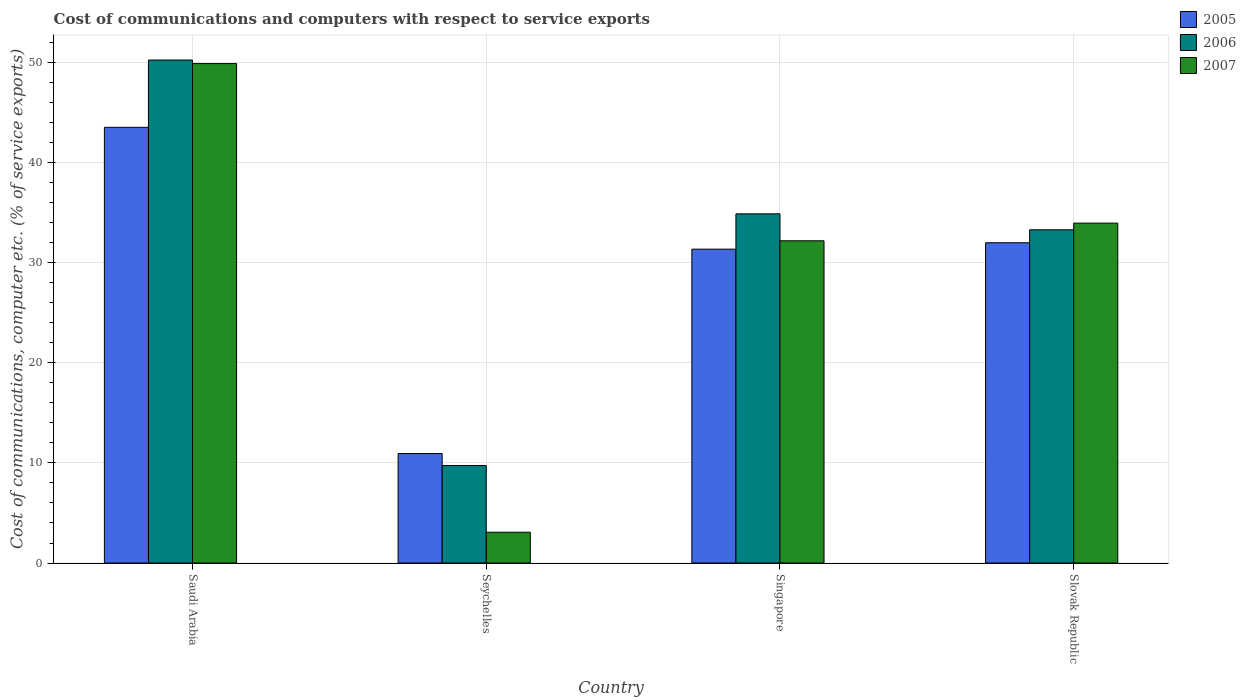How many different coloured bars are there?
Make the answer very short. 3. What is the label of the 1st group of bars from the left?
Provide a succinct answer. Saudi Arabia. What is the cost of communications and computers in 2007 in Seychelles?
Make the answer very short. 3.08. Across all countries, what is the maximum cost of communications and computers in 2006?
Offer a very short reply. 50.22. Across all countries, what is the minimum cost of communications and computers in 2006?
Your response must be concise. 9.74. In which country was the cost of communications and computers in 2007 maximum?
Your answer should be very brief. Saudi Arabia. In which country was the cost of communications and computers in 2006 minimum?
Offer a very short reply. Seychelles. What is the total cost of communications and computers in 2005 in the graph?
Your answer should be very brief. 117.76. What is the difference between the cost of communications and computers in 2007 in Seychelles and that in Slovak Republic?
Keep it short and to the point. -30.86. What is the difference between the cost of communications and computers in 2007 in Saudi Arabia and the cost of communications and computers in 2006 in Seychelles?
Your answer should be very brief. 40.13. What is the average cost of communications and computers in 2007 per country?
Your answer should be compact. 29.77. What is the difference between the cost of communications and computers of/in 2006 and cost of communications and computers of/in 2007 in Slovak Republic?
Provide a succinct answer. -0.67. In how many countries, is the cost of communications and computers in 2007 greater than 8 %?
Your answer should be compact. 3. What is the ratio of the cost of communications and computers in 2007 in Singapore to that in Slovak Republic?
Ensure brevity in your answer.  0.95. Is the cost of communications and computers in 2005 in Saudi Arabia less than that in Slovak Republic?
Make the answer very short. No. What is the difference between the highest and the second highest cost of communications and computers in 2005?
Your answer should be very brief. 12.17. What is the difference between the highest and the lowest cost of communications and computers in 2007?
Make the answer very short. 46.79. In how many countries, is the cost of communications and computers in 2005 greater than the average cost of communications and computers in 2005 taken over all countries?
Offer a very short reply. 3. What does the 1st bar from the left in Slovak Republic represents?
Offer a very short reply. 2005. Is it the case that in every country, the sum of the cost of communications and computers in 2007 and cost of communications and computers in 2005 is greater than the cost of communications and computers in 2006?
Keep it short and to the point. Yes. Are all the bars in the graph horizontal?
Offer a very short reply. No. How many legend labels are there?
Give a very brief answer. 3. What is the title of the graph?
Ensure brevity in your answer.  Cost of communications and computers with respect to service exports. Does "1985" appear as one of the legend labels in the graph?
Give a very brief answer. No. What is the label or title of the X-axis?
Offer a very short reply. Country. What is the label or title of the Y-axis?
Offer a terse response. Cost of communications, computer etc. (% of service exports). What is the Cost of communications, computer etc. (% of service exports) in 2005 in Saudi Arabia?
Your answer should be compact. 43.5. What is the Cost of communications, computer etc. (% of service exports) in 2006 in Saudi Arabia?
Your response must be concise. 50.22. What is the Cost of communications, computer etc. (% of service exports) of 2007 in Saudi Arabia?
Provide a short and direct response. 49.87. What is the Cost of communications, computer etc. (% of service exports) of 2005 in Seychelles?
Provide a succinct answer. 10.93. What is the Cost of communications, computer etc. (% of service exports) of 2006 in Seychelles?
Offer a terse response. 9.74. What is the Cost of communications, computer etc. (% of service exports) of 2007 in Seychelles?
Your response must be concise. 3.08. What is the Cost of communications, computer etc. (% of service exports) of 2005 in Singapore?
Give a very brief answer. 31.34. What is the Cost of communications, computer etc. (% of service exports) in 2006 in Singapore?
Your answer should be very brief. 34.87. What is the Cost of communications, computer etc. (% of service exports) in 2007 in Singapore?
Make the answer very short. 32.18. What is the Cost of communications, computer etc. (% of service exports) in 2005 in Slovak Republic?
Give a very brief answer. 31.98. What is the Cost of communications, computer etc. (% of service exports) of 2006 in Slovak Republic?
Your response must be concise. 33.27. What is the Cost of communications, computer etc. (% of service exports) in 2007 in Slovak Republic?
Ensure brevity in your answer.  33.94. Across all countries, what is the maximum Cost of communications, computer etc. (% of service exports) of 2005?
Keep it short and to the point. 43.5. Across all countries, what is the maximum Cost of communications, computer etc. (% of service exports) in 2006?
Your answer should be compact. 50.22. Across all countries, what is the maximum Cost of communications, computer etc. (% of service exports) in 2007?
Your response must be concise. 49.87. Across all countries, what is the minimum Cost of communications, computer etc. (% of service exports) of 2005?
Offer a very short reply. 10.93. Across all countries, what is the minimum Cost of communications, computer etc. (% of service exports) of 2006?
Give a very brief answer. 9.74. Across all countries, what is the minimum Cost of communications, computer etc. (% of service exports) of 2007?
Provide a succinct answer. 3.08. What is the total Cost of communications, computer etc. (% of service exports) in 2005 in the graph?
Your response must be concise. 117.76. What is the total Cost of communications, computer etc. (% of service exports) of 2006 in the graph?
Your response must be concise. 128.1. What is the total Cost of communications, computer etc. (% of service exports) in 2007 in the graph?
Make the answer very short. 119.06. What is the difference between the Cost of communications, computer etc. (% of service exports) in 2005 in Saudi Arabia and that in Seychelles?
Your answer should be very brief. 32.57. What is the difference between the Cost of communications, computer etc. (% of service exports) of 2006 in Saudi Arabia and that in Seychelles?
Provide a succinct answer. 40.49. What is the difference between the Cost of communications, computer etc. (% of service exports) of 2007 in Saudi Arabia and that in Seychelles?
Your answer should be compact. 46.79. What is the difference between the Cost of communications, computer etc. (% of service exports) in 2005 in Saudi Arabia and that in Singapore?
Give a very brief answer. 12.17. What is the difference between the Cost of communications, computer etc. (% of service exports) in 2006 in Saudi Arabia and that in Singapore?
Offer a terse response. 15.36. What is the difference between the Cost of communications, computer etc. (% of service exports) in 2007 in Saudi Arabia and that in Singapore?
Offer a terse response. 17.69. What is the difference between the Cost of communications, computer etc. (% of service exports) in 2005 in Saudi Arabia and that in Slovak Republic?
Ensure brevity in your answer.  11.52. What is the difference between the Cost of communications, computer etc. (% of service exports) of 2006 in Saudi Arabia and that in Slovak Republic?
Give a very brief answer. 16.95. What is the difference between the Cost of communications, computer etc. (% of service exports) in 2007 in Saudi Arabia and that in Slovak Republic?
Provide a short and direct response. 15.93. What is the difference between the Cost of communications, computer etc. (% of service exports) in 2005 in Seychelles and that in Singapore?
Your response must be concise. -20.41. What is the difference between the Cost of communications, computer etc. (% of service exports) of 2006 in Seychelles and that in Singapore?
Ensure brevity in your answer.  -25.13. What is the difference between the Cost of communications, computer etc. (% of service exports) of 2007 in Seychelles and that in Singapore?
Give a very brief answer. -29.1. What is the difference between the Cost of communications, computer etc. (% of service exports) of 2005 in Seychelles and that in Slovak Republic?
Give a very brief answer. -21.05. What is the difference between the Cost of communications, computer etc. (% of service exports) in 2006 in Seychelles and that in Slovak Republic?
Ensure brevity in your answer.  -23.54. What is the difference between the Cost of communications, computer etc. (% of service exports) in 2007 in Seychelles and that in Slovak Republic?
Your answer should be very brief. -30.86. What is the difference between the Cost of communications, computer etc. (% of service exports) in 2005 in Singapore and that in Slovak Republic?
Your answer should be compact. -0.64. What is the difference between the Cost of communications, computer etc. (% of service exports) of 2006 in Singapore and that in Slovak Republic?
Keep it short and to the point. 1.6. What is the difference between the Cost of communications, computer etc. (% of service exports) in 2007 in Singapore and that in Slovak Republic?
Provide a short and direct response. -1.76. What is the difference between the Cost of communications, computer etc. (% of service exports) of 2005 in Saudi Arabia and the Cost of communications, computer etc. (% of service exports) of 2006 in Seychelles?
Offer a very short reply. 33.77. What is the difference between the Cost of communications, computer etc. (% of service exports) in 2005 in Saudi Arabia and the Cost of communications, computer etc. (% of service exports) in 2007 in Seychelles?
Provide a succinct answer. 40.43. What is the difference between the Cost of communications, computer etc. (% of service exports) of 2006 in Saudi Arabia and the Cost of communications, computer etc. (% of service exports) of 2007 in Seychelles?
Offer a very short reply. 47.15. What is the difference between the Cost of communications, computer etc. (% of service exports) in 2005 in Saudi Arabia and the Cost of communications, computer etc. (% of service exports) in 2006 in Singapore?
Your answer should be very brief. 8.64. What is the difference between the Cost of communications, computer etc. (% of service exports) of 2005 in Saudi Arabia and the Cost of communications, computer etc. (% of service exports) of 2007 in Singapore?
Keep it short and to the point. 11.33. What is the difference between the Cost of communications, computer etc. (% of service exports) of 2006 in Saudi Arabia and the Cost of communications, computer etc. (% of service exports) of 2007 in Singapore?
Your response must be concise. 18.05. What is the difference between the Cost of communications, computer etc. (% of service exports) of 2005 in Saudi Arabia and the Cost of communications, computer etc. (% of service exports) of 2006 in Slovak Republic?
Your answer should be very brief. 10.23. What is the difference between the Cost of communications, computer etc. (% of service exports) of 2005 in Saudi Arabia and the Cost of communications, computer etc. (% of service exports) of 2007 in Slovak Republic?
Your answer should be very brief. 9.56. What is the difference between the Cost of communications, computer etc. (% of service exports) in 2006 in Saudi Arabia and the Cost of communications, computer etc. (% of service exports) in 2007 in Slovak Republic?
Offer a very short reply. 16.28. What is the difference between the Cost of communications, computer etc. (% of service exports) in 2005 in Seychelles and the Cost of communications, computer etc. (% of service exports) in 2006 in Singapore?
Your response must be concise. -23.94. What is the difference between the Cost of communications, computer etc. (% of service exports) in 2005 in Seychelles and the Cost of communications, computer etc. (% of service exports) in 2007 in Singapore?
Your response must be concise. -21.24. What is the difference between the Cost of communications, computer etc. (% of service exports) of 2006 in Seychelles and the Cost of communications, computer etc. (% of service exports) of 2007 in Singapore?
Provide a short and direct response. -22.44. What is the difference between the Cost of communications, computer etc. (% of service exports) of 2005 in Seychelles and the Cost of communications, computer etc. (% of service exports) of 2006 in Slovak Republic?
Offer a terse response. -22.34. What is the difference between the Cost of communications, computer etc. (% of service exports) of 2005 in Seychelles and the Cost of communications, computer etc. (% of service exports) of 2007 in Slovak Republic?
Offer a very short reply. -23.01. What is the difference between the Cost of communications, computer etc. (% of service exports) in 2006 in Seychelles and the Cost of communications, computer etc. (% of service exports) in 2007 in Slovak Republic?
Give a very brief answer. -24.2. What is the difference between the Cost of communications, computer etc. (% of service exports) of 2005 in Singapore and the Cost of communications, computer etc. (% of service exports) of 2006 in Slovak Republic?
Keep it short and to the point. -1.93. What is the difference between the Cost of communications, computer etc. (% of service exports) in 2005 in Singapore and the Cost of communications, computer etc. (% of service exports) in 2007 in Slovak Republic?
Keep it short and to the point. -2.6. What is the difference between the Cost of communications, computer etc. (% of service exports) of 2006 in Singapore and the Cost of communications, computer etc. (% of service exports) of 2007 in Slovak Republic?
Make the answer very short. 0.93. What is the average Cost of communications, computer etc. (% of service exports) in 2005 per country?
Ensure brevity in your answer.  29.44. What is the average Cost of communications, computer etc. (% of service exports) of 2006 per country?
Make the answer very short. 32.02. What is the average Cost of communications, computer etc. (% of service exports) of 2007 per country?
Your response must be concise. 29.77. What is the difference between the Cost of communications, computer etc. (% of service exports) of 2005 and Cost of communications, computer etc. (% of service exports) of 2006 in Saudi Arabia?
Provide a short and direct response. -6.72. What is the difference between the Cost of communications, computer etc. (% of service exports) in 2005 and Cost of communications, computer etc. (% of service exports) in 2007 in Saudi Arabia?
Provide a short and direct response. -6.37. What is the difference between the Cost of communications, computer etc. (% of service exports) in 2006 and Cost of communications, computer etc. (% of service exports) in 2007 in Saudi Arabia?
Ensure brevity in your answer.  0.36. What is the difference between the Cost of communications, computer etc. (% of service exports) in 2005 and Cost of communications, computer etc. (% of service exports) in 2006 in Seychelles?
Your answer should be compact. 1.2. What is the difference between the Cost of communications, computer etc. (% of service exports) of 2005 and Cost of communications, computer etc. (% of service exports) of 2007 in Seychelles?
Provide a short and direct response. 7.85. What is the difference between the Cost of communications, computer etc. (% of service exports) of 2006 and Cost of communications, computer etc. (% of service exports) of 2007 in Seychelles?
Offer a very short reply. 6.66. What is the difference between the Cost of communications, computer etc. (% of service exports) of 2005 and Cost of communications, computer etc. (% of service exports) of 2006 in Singapore?
Offer a very short reply. -3.53. What is the difference between the Cost of communications, computer etc. (% of service exports) in 2005 and Cost of communications, computer etc. (% of service exports) in 2007 in Singapore?
Your answer should be compact. -0.84. What is the difference between the Cost of communications, computer etc. (% of service exports) of 2006 and Cost of communications, computer etc. (% of service exports) of 2007 in Singapore?
Give a very brief answer. 2.69. What is the difference between the Cost of communications, computer etc. (% of service exports) in 2005 and Cost of communications, computer etc. (% of service exports) in 2006 in Slovak Republic?
Give a very brief answer. -1.29. What is the difference between the Cost of communications, computer etc. (% of service exports) in 2005 and Cost of communications, computer etc. (% of service exports) in 2007 in Slovak Republic?
Ensure brevity in your answer.  -1.96. What is the difference between the Cost of communications, computer etc. (% of service exports) of 2006 and Cost of communications, computer etc. (% of service exports) of 2007 in Slovak Republic?
Provide a short and direct response. -0.67. What is the ratio of the Cost of communications, computer etc. (% of service exports) of 2005 in Saudi Arabia to that in Seychelles?
Provide a short and direct response. 3.98. What is the ratio of the Cost of communications, computer etc. (% of service exports) of 2006 in Saudi Arabia to that in Seychelles?
Your answer should be compact. 5.16. What is the ratio of the Cost of communications, computer etc. (% of service exports) of 2007 in Saudi Arabia to that in Seychelles?
Offer a very short reply. 16.2. What is the ratio of the Cost of communications, computer etc. (% of service exports) in 2005 in Saudi Arabia to that in Singapore?
Your answer should be compact. 1.39. What is the ratio of the Cost of communications, computer etc. (% of service exports) in 2006 in Saudi Arabia to that in Singapore?
Your answer should be compact. 1.44. What is the ratio of the Cost of communications, computer etc. (% of service exports) of 2007 in Saudi Arabia to that in Singapore?
Keep it short and to the point. 1.55. What is the ratio of the Cost of communications, computer etc. (% of service exports) of 2005 in Saudi Arabia to that in Slovak Republic?
Your response must be concise. 1.36. What is the ratio of the Cost of communications, computer etc. (% of service exports) in 2006 in Saudi Arabia to that in Slovak Republic?
Ensure brevity in your answer.  1.51. What is the ratio of the Cost of communications, computer etc. (% of service exports) of 2007 in Saudi Arabia to that in Slovak Republic?
Your answer should be very brief. 1.47. What is the ratio of the Cost of communications, computer etc. (% of service exports) of 2005 in Seychelles to that in Singapore?
Make the answer very short. 0.35. What is the ratio of the Cost of communications, computer etc. (% of service exports) in 2006 in Seychelles to that in Singapore?
Make the answer very short. 0.28. What is the ratio of the Cost of communications, computer etc. (% of service exports) in 2007 in Seychelles to that in Singapore?
Offer a terse response. 0.1. What is the ratio of the Cost of communications, computer etc. (% of service exports) of 2005 in Seychelles to that in Slovak Republic?
Offer a very short reply. 0.34. What is the ratio of the Cost of communications, computer etc. (% of service exports) in 2006 in Seychelles to that in Slovak Republic?
Your response must be concise. 0.29. What is the ratio of the Cost of communications, computer etc. (% of service exports) of 2007 in Seychelles to that in Slovak Republic?
Provide a succinct answer. 0.09. What is the ratio of the Cost of communications, computer etc. (% of service exports) of 2005 in Singapore to that in Slovak Republic?
Your answer should be very brief. 0.98. What is the ratio of the Cost of communications, computer etc. (% of service exports) of 2006 in Singapore to that in Slovak Republic?
Provide a succinct answer. 1.05. What is the ratio of the Cost of communications, computer etc. (% of service exports) of 2007 in Singapore to that in Slovak Republic?
Offer a terse response. 0.95. What is the difference between the highest and the second highest Cost of communications, computer etc. (% of service exports) of 2005?
Your answer should be very brief. 11.52. What is the difference between the highest and the second highest Cost of communications, computer etc. (% of service exports) in 2006?
Your answer should be very brief. 15.36. What is the difference between the highest and the second highest Cost of communications, computer etc. (% of service exports) in 2007?
Keep it short and to the point. 15.93. What is the difference between the highest and the lowest Cost of communications, computer etc. (% of service exports) in 2005?
Offer a terse response. 32.57. What is the difference between the highest and the lowest Cost of communications, computer etc. (% of service exports) in 2006?
Ensure brevity in your answer.  40.49. What is the difference between the highest and the lowest Cost of communications, computer etc. (% of service exports) of 2007?
Your answer should be very brief. 46.79. 